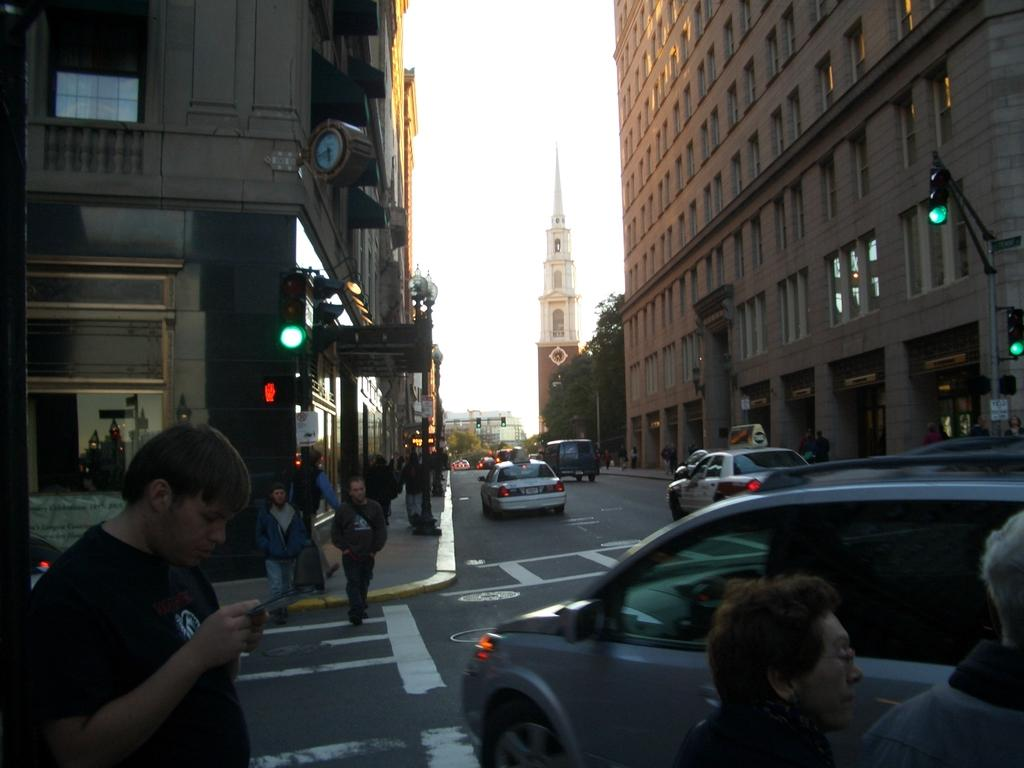What can be seen on the road in the image? There are vehicles on the road in the image. What type of structures are visible in the image? There are buildings in the image. What architectural feature can be seen in the image? There are windows in the image. What traffic control devices are present in the image? There are signal lights in the image. Who or what is present in the image? There are people in the image. What time-related object is visible in the image? There is a clock in the image. What distant landmark can be seen in the image? There is a tower in the distance. What natural elements are visible in the distance? There are trees in the distance. What action is a person performing in the image? There is a person holding an object. How many legs does the trail have in the image? There is no trail present in the image, so it is not possible to determine the number of legs. What type of agreement is being discussed by the people in the image? There is no indication in the image that any agreements are being discussed; the people are not engaged in any such activity. 